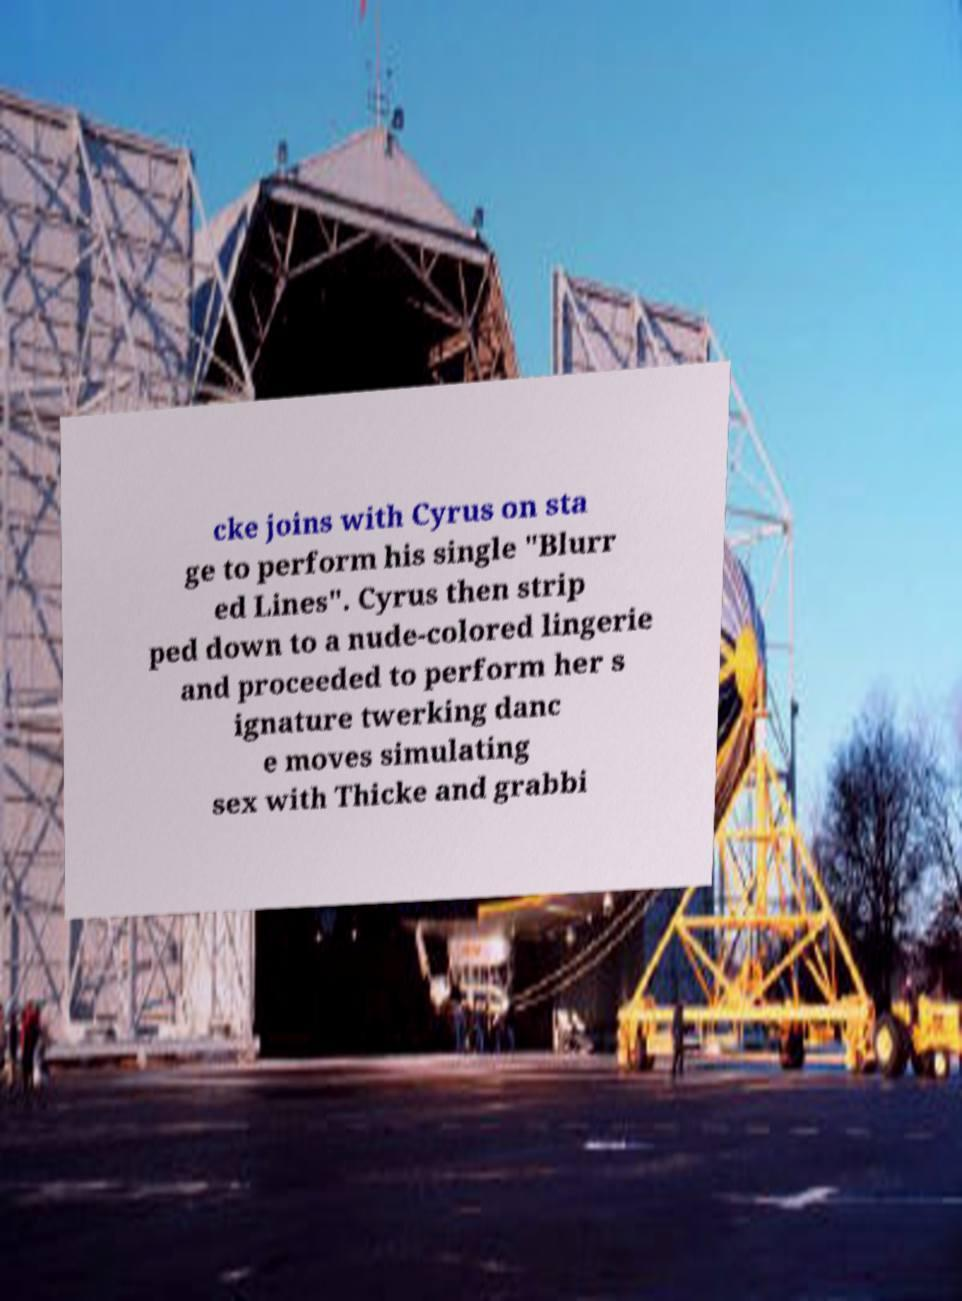Can you accurately transcribe the text from the provided image for me? cke joins with Cyrus on sta ge to perform his single "Blurr ed Lines". Cyrus then strip ped down to a nude-colored lingerie and proceeded to perform her s ignature twerking danc e moves simulating sex with Thicke and grabbi 